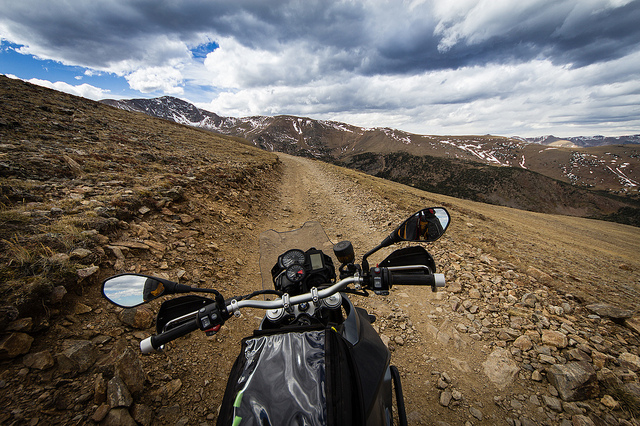Is it cloudy? Yes, the sky is filled with numerous clouds suggesting overcast weather, but there are also some breaks in the cloud cover allowing for patches of blue sky. 